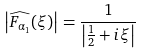<formula> <loc_0><loc_0><loc_500><loc_500>\left | \widehat { F _ { \alpha _ { 1 } } } ( \xi ) \right | = \frac { 1 } { \left | \frac { 1 } { 2 } + i \xi \right | }</formula> 